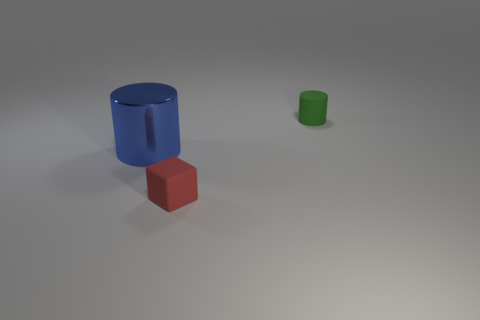Is the number of small red cubes that are in front of the big cylinder greater than the number of blue balls?
Give a very brief answer. Yes. There is a matte cylinder that is the same size as the red object; what is its color?
Provide a short and direct response. Green. How many objects are either rubber cubes that are on the right side of the large metal object or small red rubber objects?
Make the answer very short. 1. What is the material of the cylinder to the left of the matte thing in front of the tiny green cylinder?
Provide a short and direct response. Metal. Is there a tiny cylinder that has the same material as the small red cube?
Offer a terse response. Yes. There is a cylinder to the right of the big shiny cylinder; is there a blue cylinder that is in front of it?
Provide a short and direct response. Yes. There is a blue thing that is behind the red block; what is it made of?
Make the answer very short. Metal. Is the blue thing the same shape as the tiny green thing?
Make the answer very short. Yes. The tiny object that is in front of the cylinder behind the big blue shiny thing that is behind the small red matte block is what color?
Give a very brief answer. Red. What number of other small red objects have the same shape as the red object?
Keep it short and to the point. 0. 